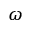<formula> <loc_0><loc_0><loc_500><loc_500>\omega</formula> 